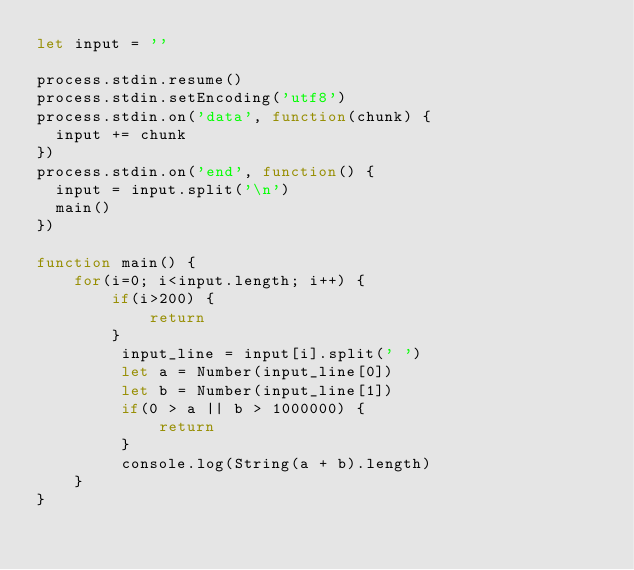Convert code to text. <code><loc_0><loc_0><loc_500><loc_500><_JavaScript_>let input = ''

process.stdin.resume()
process.stdin.setEncoding('utf8')
process.stdin.on('data', function(chunk) {
  input += chunk
})
process.stdin.on('end', function() {
  input = input.split('\n')
  main()
})

function main() {
    for(i=0; i<input.length; i++) {
        if(i>200) {
            return
        }
         input_line = input[i].split(' ')
         let a = Number(input_line[0])
         let b = Number(input_line[1])
         if(0 > a || b > 1000000) {
             return
         }
         console.log(String(a + b).length)
    }
}
</code> 